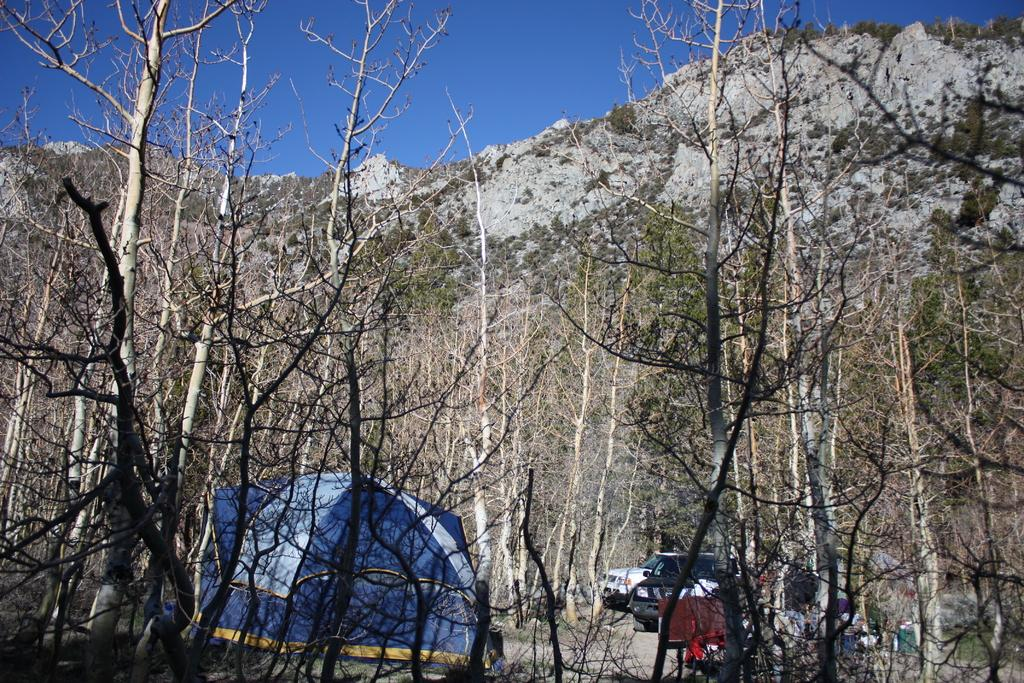What type of natural environment is depicted in the image? The image features trees and mountains, indicating a natural environment. What objects can be seen among the trees? There are vehicles parked and a tent in the middle of the trees. What is visible in the background of the image? There is a sky visible in the background of the image. What type of game is being played in the image? There is no game being played in the image; it features a natural environment with trees, mountains, vehicles, and a tent. Can you describe the partner who is participating in the game? There is no partner or game present in the image, so it is not possible to describe a partner. 